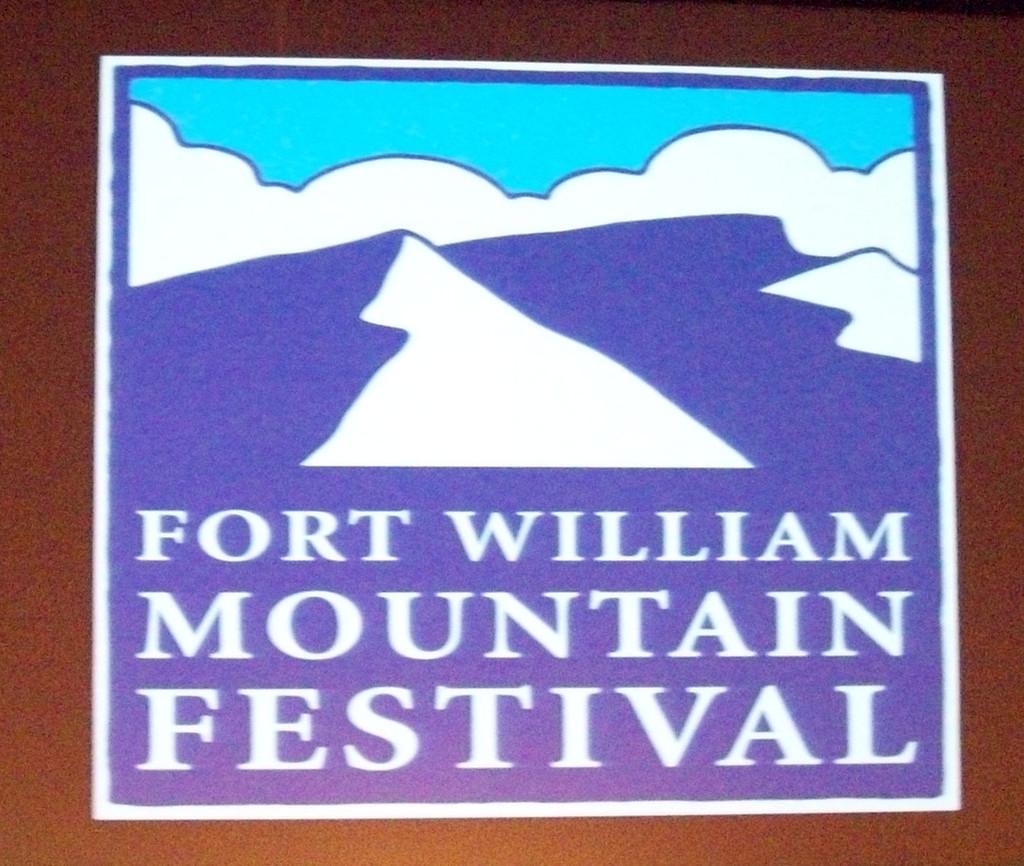What festival is shown?
Ensure brevity in your answer.  Fort william mountain festival. This is tv?
Offer a terse response. Unanswerable. 